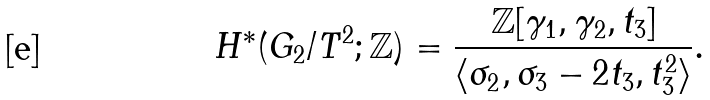<formula> <loc_0><loc_0><loc_500><loc_500>H ^ { * } ( G _ { 2 } / T ^ { 2 } ; \mathbb { Z } ) = \frac { \mathbb { Z } [ \gamma _ { 1 } , \gamma _ { 2 } , t _ { 3 } ] } { \langle \sigma _ { 2 } , \sigma _ { 3 } - 2 t _ { 3 } , t _ { 3 } ^ { 2 } \rangle } .</formula> 